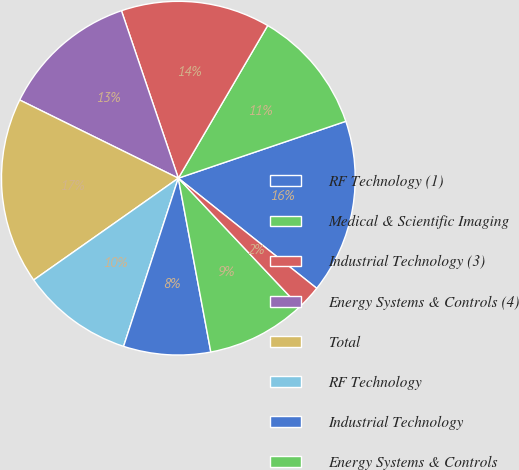<chart> <loc_0><loc_0><loc_500><loc_500><pie_chart><fcel>RF Technology (1)<fcel>Medical & Scientific Imaging<fcel>Industrial Technology (3)<fcel>Energy Systems & Controls (4)<fcel>Total<fcel>RF Technology<fcel>Industrial Technology<fcel>Energy Systems & Controls<fcel>Corporate administrative<nl><fcel>15.91%<fcel>11.36%<fcel>13.64%<fcel>12.5%<fcel>17.05%<fcel>10.23%<fcel>7.95%<fcel>9.09%<fcel>2.27%<nl></chart> 